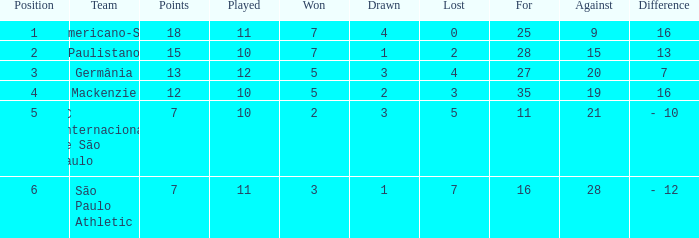Specify the lowest for when performed is 1 27.0. 